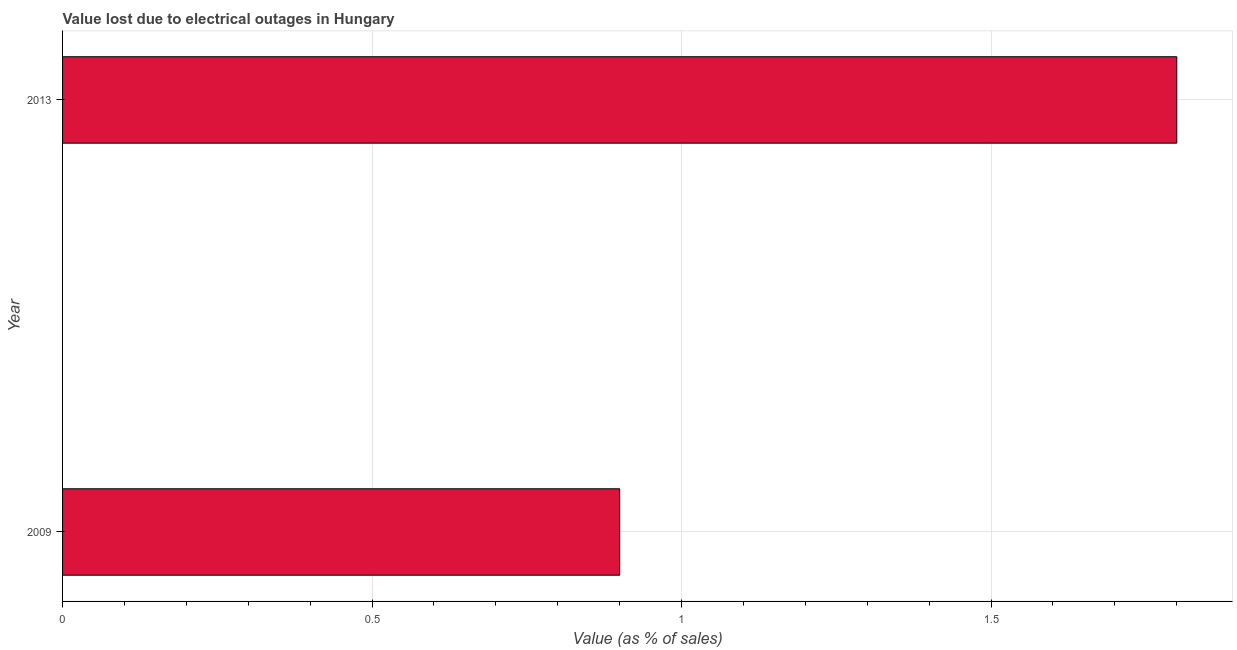Does the graph contain any zero values?
Provide a short and direct response. No. What is the title of the graph?
Your answer should be very brief. Value lost due to electrical outages in Hungary. What is the label or title of the X-axis?
Your response must be concise. Value (as % of sales). What is the label or title of the Y-axis?
Your response must be concise. Year. What is the value lost due to electrical outages in 2009?
Your answer should be compact. 0.9. Across all years, what is the maximum value lost due to electrical outages?
Ensure brevity in your answer.  1.8. In which year was the value lost due to electrical outages maximum?
Keep it short and to the point. 2013. What is the sum of the value lost due to electrical outages?
Provide a succinct answer. 2.7. What is the average value lost due to electrical outages per year?
Your response must be concise. 1.35. What is the median value lost due to electrical outages?
Offer a terse response. 1.35. How many bars are there?
Make the answer very short. 2. Are all the bars in the graph horizontal?
Make the answer very short. Yes. How many years are there in the graph?
Keep it short and to the point. 2. What is the difference between two consecutive major ticks on the X-axis?
Your answer should be compact. 0.5. What is the Value (as % of sales) of 2009?
Make the answer very short. 0.9. What is the Value (as % of sales) of 2013?
Provide a short and direct response. 1.8. What is the ratio of the Value (as % of sales) in 2009 to that in 2013?
Make the answer very short. 0.5. 